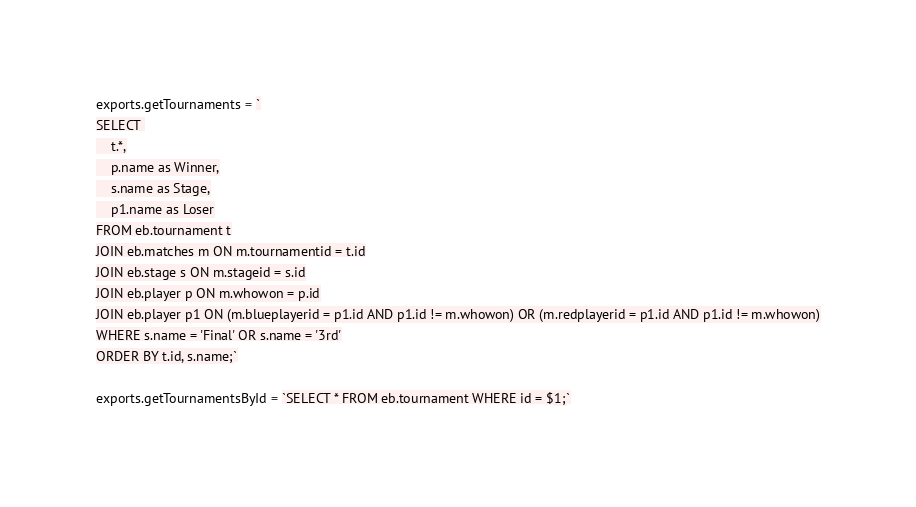<code> <loc_0><loc_0><loc_500><loc_500><_JavaScript_>exports.getTournaments = `
SELECT 
	t.*,
	p.name as Winner,
	s.name as Stage,
	p1.name as Loser
FROM eb.tournament t
JOIN eb.matches m ON m.tournamentid = t.id
JOIN eb.stage s ON m.stageid = s.id
JOIN eb.player p ON m.whowon = p.id
JOIN eb.player p1 ON (m.blueplayerid = p1.id AND p1.id != m.whowon) OR (m.redplayerid = p1.id AND p1.id != m.whowon)
WHERE s.name = 'Final' OR s.name = '3rd'
ORDER BY t.id, s.name;`

exports.getTournamentsById = `SELECT * FROM eb.tournament WHERE id = $1;`</code> 